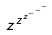Convert formula to latex. <formula><loc_0><loc_0><loc_500><loc_500>z ^ { z ^ { z ^ { - ^ { - ^ { - } } } } }</formula> 